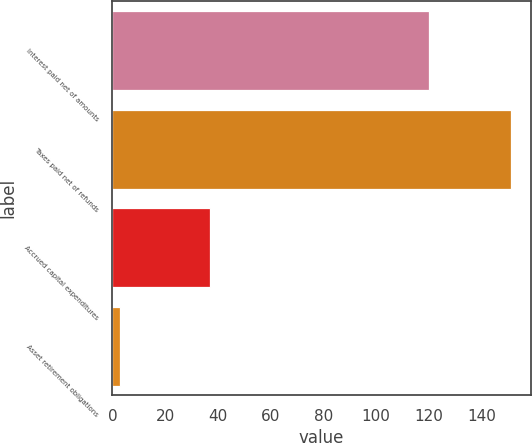Convert chart. <chart><loc_0><loc_0><loc_500><loc_500><bar_chart><fcel>Interest paid net of amounts<fcel>Taxes paid net of refunds<fcel>Accrued capital expenditures<fcel>Asset retirement obligations<nl><fcel>120<fcel>151<fcel>37<fcel>3<nl></chart> 